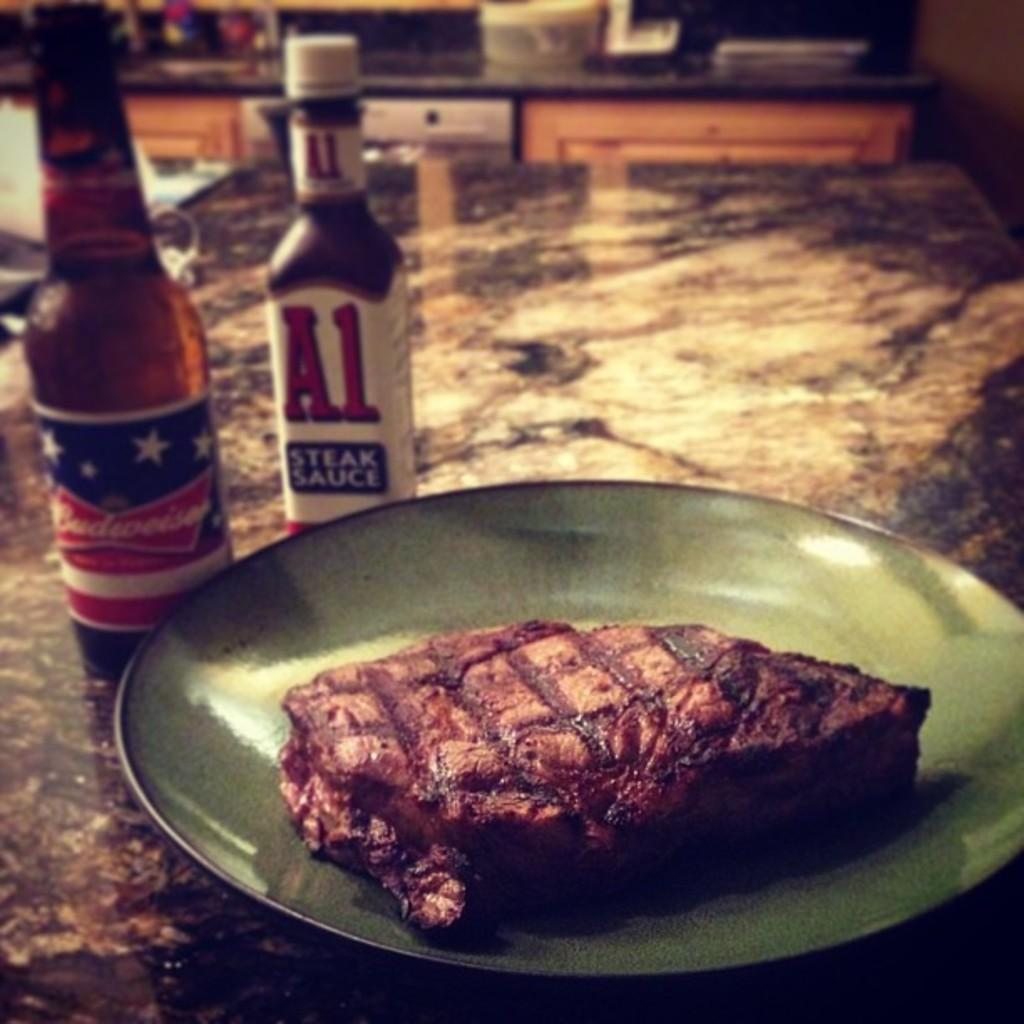<image>
Create a compact narrative representing the image presented. A bottle of A1 sauce is behind a plate with a steak on it. 